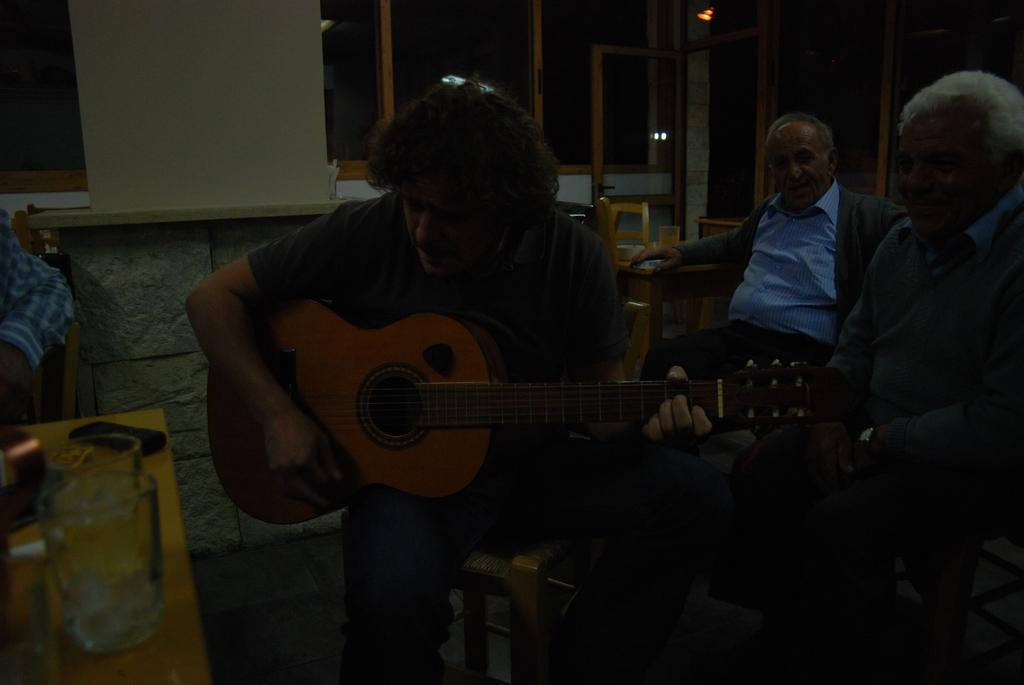How many men are in the image? There are three men in the image. What are the men doing in the image? The men are sitting on chairs. Can you describe any objects the men are holding? One man is holding a guitar. What else can be seen on the tables in the image? There are glasses on the tables. What is visible in the background of the image? There is a wall in the background of the image. What type of horn can be heard in the image? There is no horn present in the image, and therefore no sound can be heard. What is the base of the guitar made of in the image? The image does not provide information about the material of the guitar's base. 